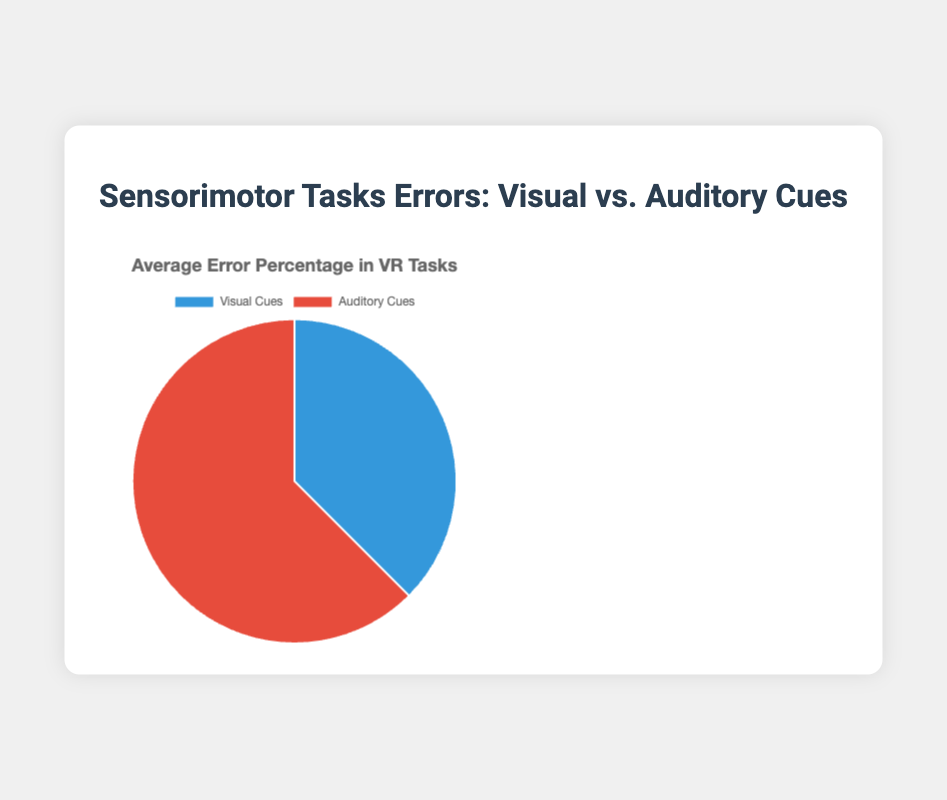What are the average error percentages for visual and auditory cues in VR tasks? To find the average error percentages, add the error values for each cue type and then divide by the number of tasks. For visual cues: (15 + 12 + 20 + 10) / 4 = 14.25%. For auditory cues: (25 + 18 + 30 + 22) / 4 = 23.75%
Answer: Visual: 14.25%, Auditory: 23.75% Which cue type results in a higher average error percentage? Compare the average error percentages calculated for visual cues (14.25%) and auditory cues (23.75%). The auditory cues have the higher average error percentage.
Answer: Auditory cues By how many percentage points do the auditory cues' average errors exceed the visual cues' average errors? Subtract the average error percentage of visual cues from that of auditory cues: 23.75% - 14.25% = 9.5 percentage points
Answer: 9.5 percentage points Which cue type is indicated by the red color segment in the pie chart? The pie chart uses red for auditory cues, as indicated in the provided configuration of the chart's color scheme.
Answer: Auditory cues What is the combined error percentage of visual and auditory cues for the task "Spatial navigation in VR"? Add the error percentages for visual (10%) and auditory (22%) cues: 10% + 22% = 32%
Answer: 32% Which cue type shows a lower error percentage for the "Balance and posture control in VR" task? Compare the error percentages for visual cues (20%) and auditory cues (30%) for this task. Visual cues have a lower error percentage.
Answer: Visual cues By how much does the error percentage for visual cues in "Hand-eye coordination in VR" differ from that in "Object manipulation in VR"? Subtract the error percentages: 15% (Hand-eye coordination) - 12% (Object manipulation) = 3 percentage points
Answer: 3 percentage points Is the error percentage for auditory cues in "Object manipulation in VR" more than the average error percentage for visual cues across all tasks? The error percentage for auditory cues in "Object manipulation in VR" is 18%. The average error percentage for visual cues is 14.25%. Since 18% > 14.25%, auditory errors in "Object manipulation in VR" exceed the average.
Answer: Yes 